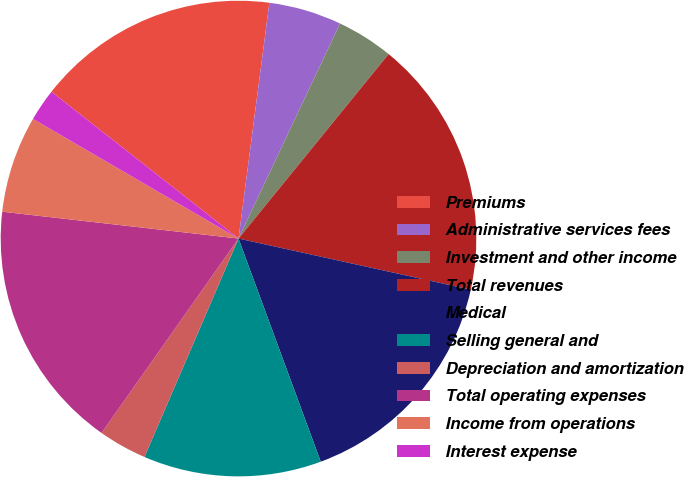Convert chart to OTSL. <chart><loc_0><loc_0><loc_500><loc_500><pie_chart><fcel>Premiums<fcel>Administrative services fees<fcel>Investment and other income<fcel>Total revenues<fcel>Medical<fcel>Selling general and<fcel>Depreciation and amortization<fcel>Total operating expenses<fcel>Income from operations<fcel>Interest expense<nl><fcel>16.48%<fcel>4.95%<fcel>3.85%<fcel>17.58%<fcel>15.93%<fcel>12.09%<fcel>3.3%<fcel>17.03%<fcel>6.59%<fcel>2.2%<nl></chart> 